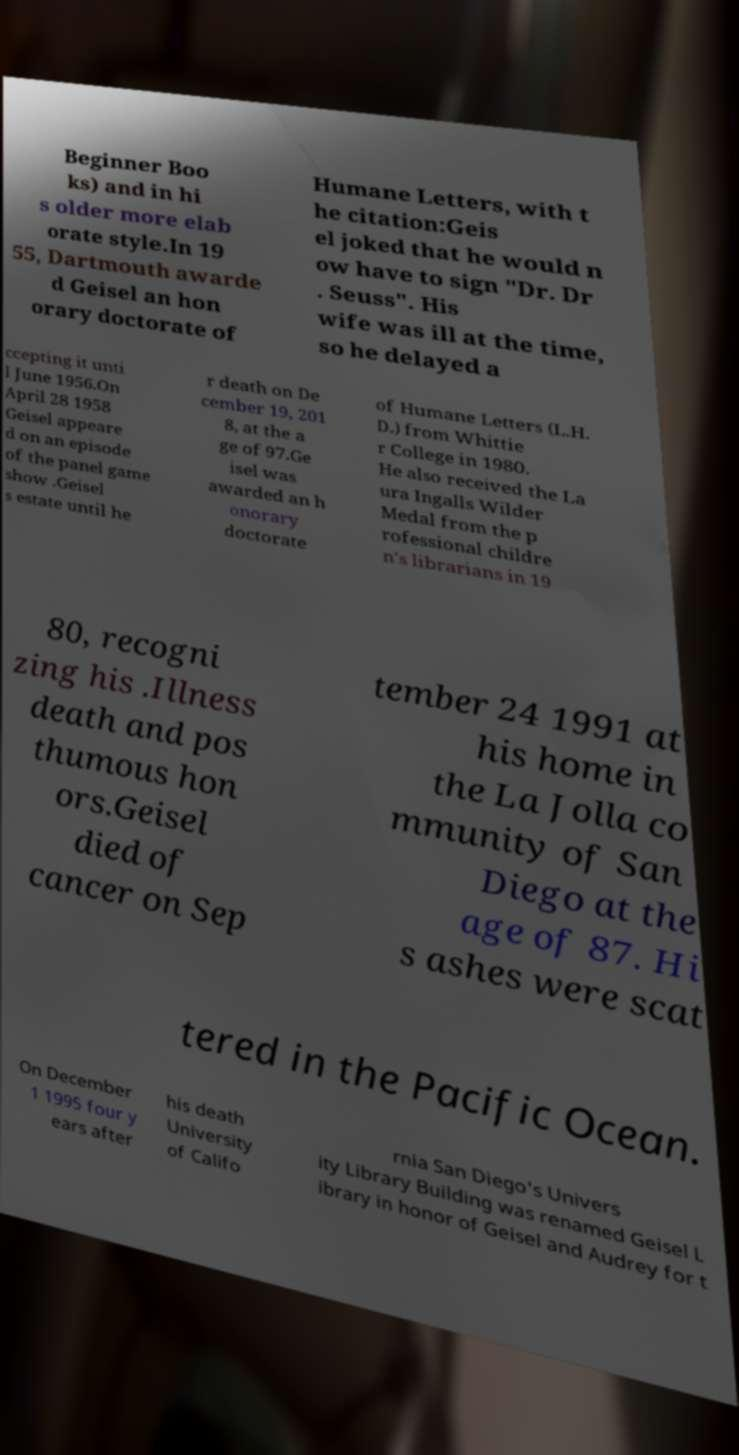What messages or text are displayed in this image? I need them in a readable, typed format. Beginner Boo ks) and in hi s older more elab orate style.In 19 55, Dartmouth awarde d Geisel an hon orary doctorate of Humane Letters, with t he citation:Geis el joked that he would n ow have to sign "Dr. Dr . Seuss". His wife was ill at the time, so he delayed a ccepting it unti l June 1956.On April 28 1958 Geisel appeare d on an episode of the panel game show .Geisel s estate until he r death on De cember 19, 201 8, at the a ge of 97.Ge isel was awarded an h onorary doctorate of Humane Letters (L.H. D.) from Whittie r College in 1980. He also received the La ura Ingalls Wilder Medal from the p rofessional childre n's librarians in 19 80, recogni zing his .Illness death and pos thumous hon ors.Geisel died of cancer on Sep tember 24 1991 at his home in the La Jolla co mmunity of San Diego at the age of 87. Hi s ashes were scat tered in the Pacific Ocean. On December 1 1995 four y ears after his death University of Califo rnia San Diego's Univers ity Library Building was renamed Geisel L ibrary in honor of Geisel and Audrey for t 